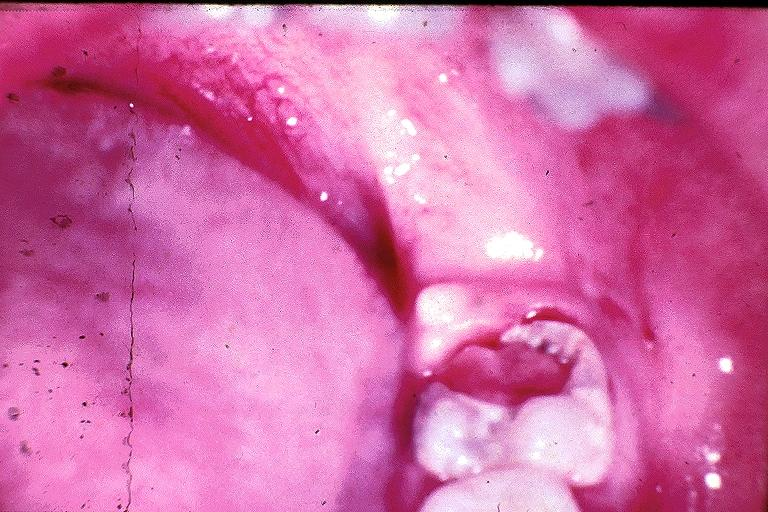what is present?
Answer the question using a single word or phrase. Oral 